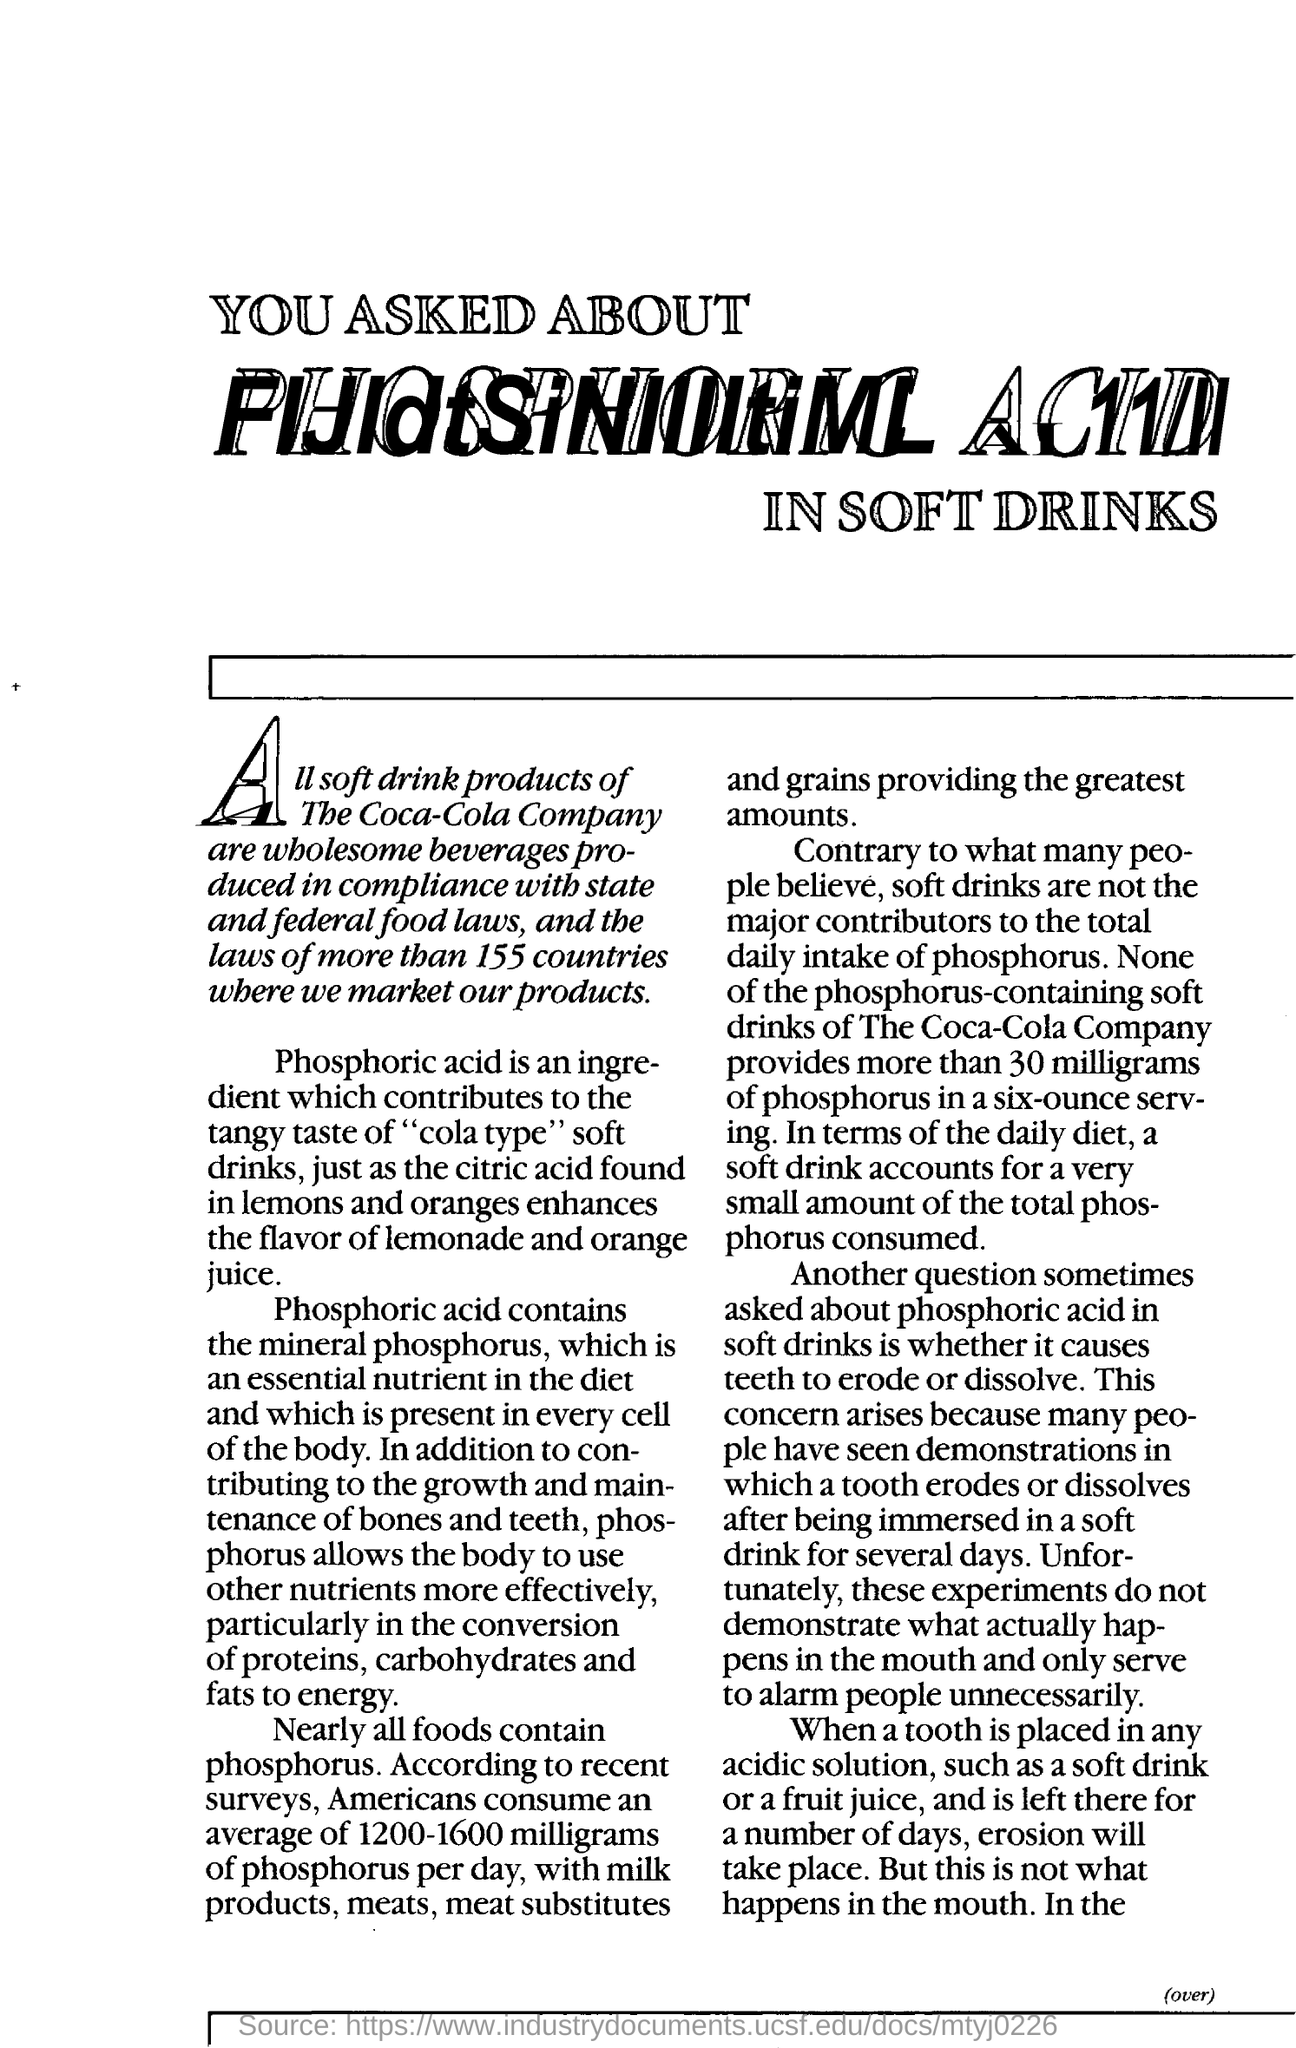Draw attention to some important aspects in this diagram. On average, Americans consume between 1200 and 1600 milligrams of phosphorus per day. Phosphoric acid contains mineral phosphorous. When a tooth is placed in an acid solution and left there for a number of days, erosion will occur. 